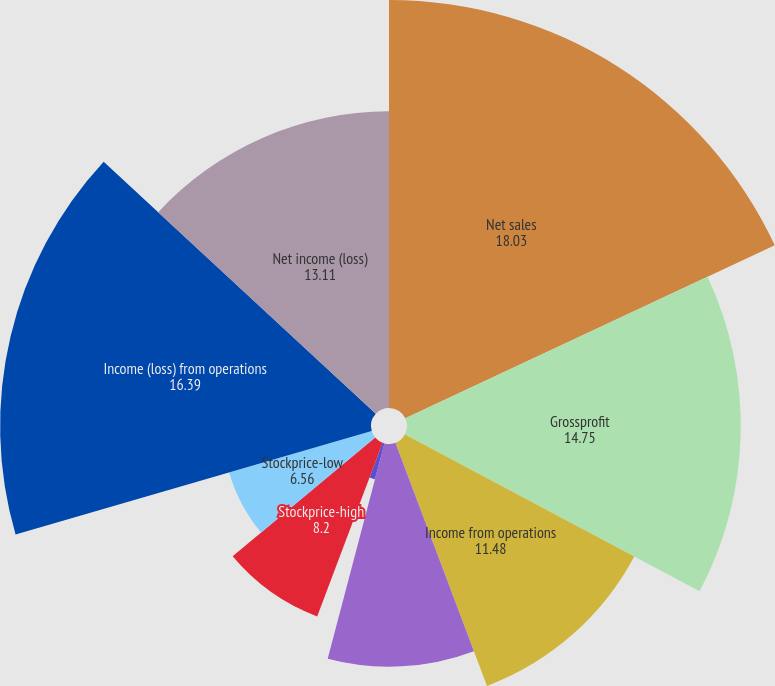<chart> <loc_0><loc_0><loc_500><loc_500><pie_chart><fcel>Net sales<fcel>Grossprofit<fcel>Income from operations<fcel>Net income<fcel>Basic earnings pershare<fcel>Diluted earnings pershare<fcel>Stockprice-high<fcel>Stockprice-low<fcel>Income (loss) from operations<fcel>Net income (loss)<nl><fcel>18.03%<fcel>14.75%<fcel>11.48%<fcel>9.84%<fcel>0.0%<fcel>1.64%<fcel>8.2%<fcel>6.56%<fcel>16.39%<fcel>13.11%<nl></chart> 